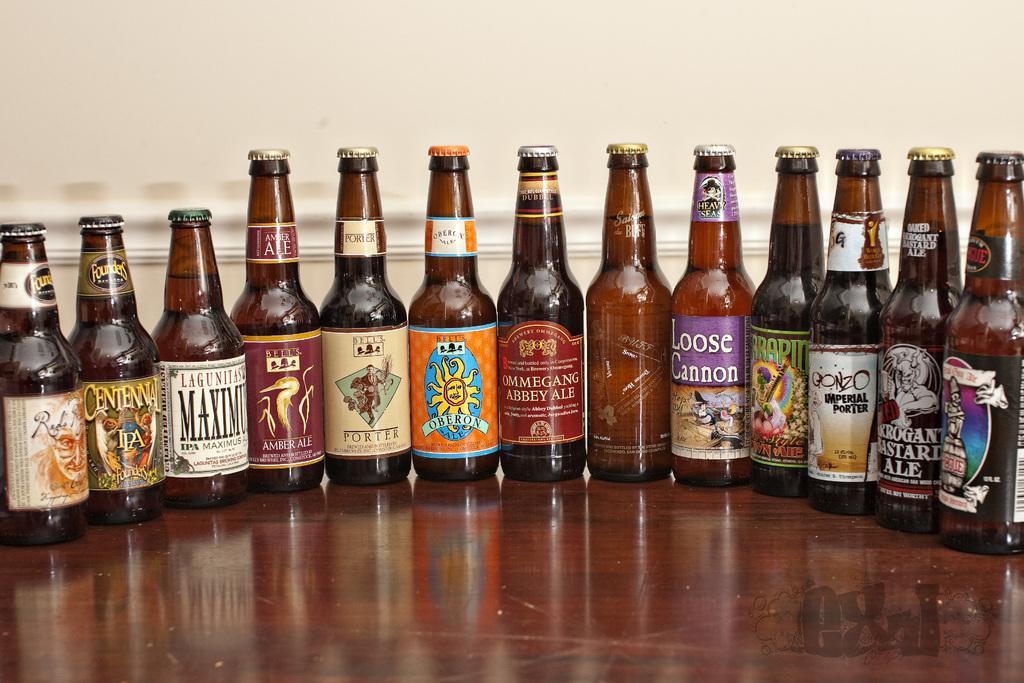In one or two sentences, can you explain what this image depicts? In this image I can see few bottles on the table. 